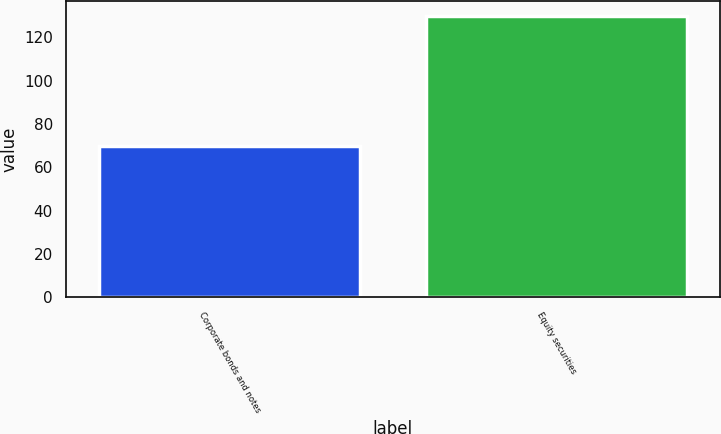Convert chart. <chart><loc_0><loc_0><loc_500><loc_500><bar_chart><fcel>Corporate bonds and notes<fcel>Equity securities<nl><fcel>70<fcel>130<nl></chart> 